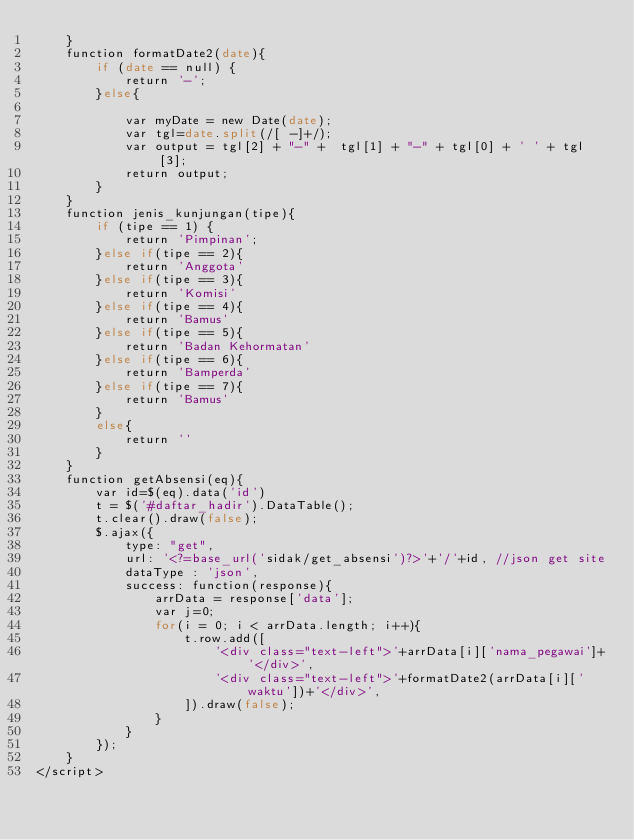<code> <loc_0><loc_0><loc_500><loc_500><_PHP_>    }
    function formatDate2(date){
        if (date == null) {
            return '-';
        }else{

            var myDate = new Date(date);
            var tgl=date.split(/[ -]+/);
            var output = tgl[2] + "-" +  tgl[1] + "-" + tgl[0] + ' ' + tgl[3];
            return output;
        }
    }
    function jenis_kunjungan(tipe){
        if (tipe == 1) {
            return 'Pimpinan';
        }else if(tipe == 2){
            return 'Anggota'
        }else if(tipe == 3){
            return 'Komisi'
        }else if(tipe == 4){
            return 'Bamus'
        }else if(tipe == 5){
            return 'Badan Kehormatan'
        }else if(tipe == 6){
            return 'Bamperda'
        }else if(tipe == 7){
            return 'Bamus'
        }
        else{
            return ''
        }
    }
    function getAbsensi(eq){
        var id=$(eq).data('id')
        t = $('#daftar_hadir').DataTable();
        t.clear().draw(false);
        $.ajax({
            type: "get",
            url: '<?=base_url('sidak/get_absensi')?>'+'/'+id, //json get site
            dataType : 'json',
            success: function(response){
                arrData = response['data'];
                var j=0;
                for(i = 0; i < arrData.length; i++){
                    t.row.add([
                        '<div class="text-left">'+arrData[i]['nama_pegawai']+'</div>',
                        '<div class="text-left">'+formatDate2(arrData[i]['waktu'])+'</div>',
                    ]).draw(false);
                }
            }
        });
    }
</script></code> 